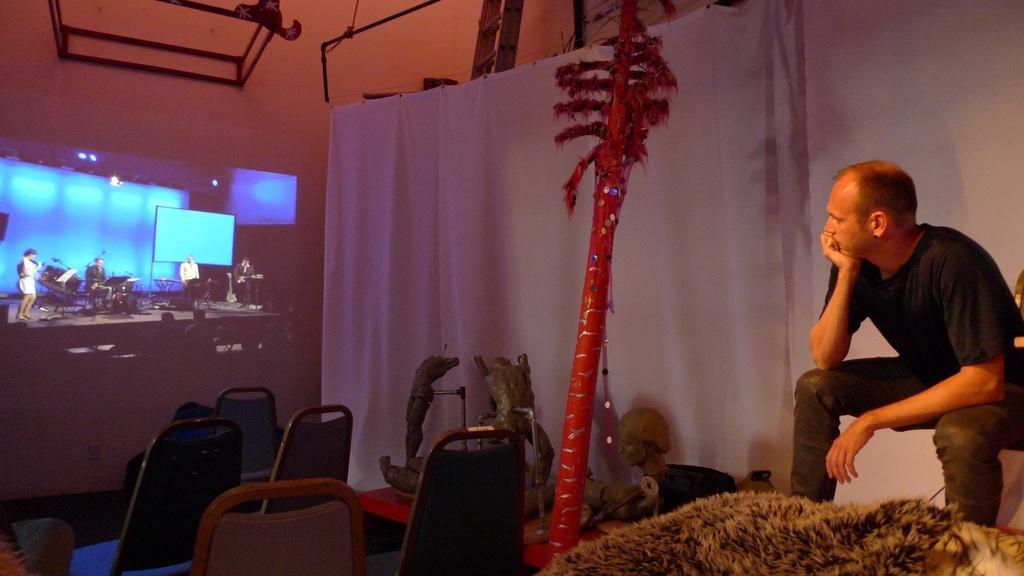How would you summarize this image in a sentence or two? This is an inside view. On the right side there is a man sitting and looking at the screen which is on the left side. On the screen, I can see few people are playing some musical instrument on the stage. At the bottom there are few empty chairs and few objects. At the back of this man there is a white color curtain. In the background there is a wall. 